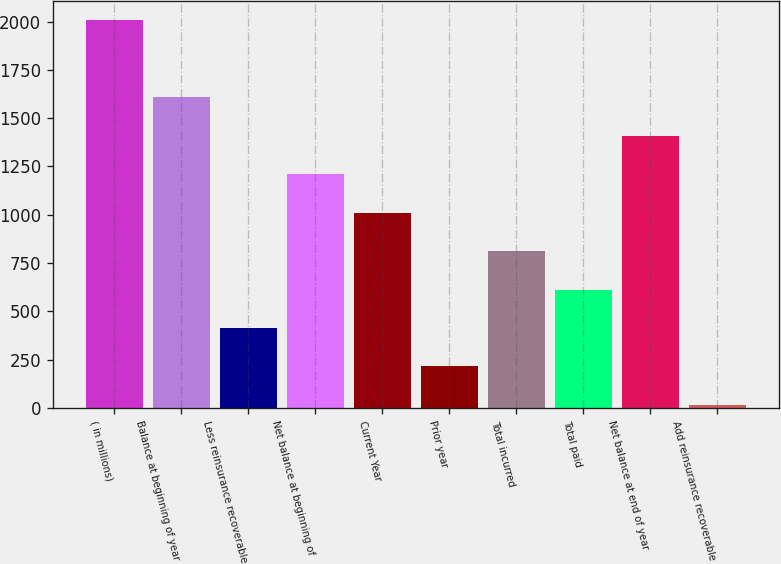<chart> <loc_0><loc_0><loc_500><loc_500><bar_chart><fcel>( in millions)<fcel>Balance at beginning of year<fcel>Less reinsurance recoverable<fcel>Net balance at beginning of<fcel>Current Year<fcel>Prior year<fcel>Total incurred<fcel>Total paid<fcel>Net balance at end of year<fcel>Add reinsurance recoverable<nl><fcel>2006<fcel>1608<fcel>414<fcel>1210<fcel>1011<fcel>215<fcel>812<fcel>613<fcel>1409<fcel>16<nl></chart> 